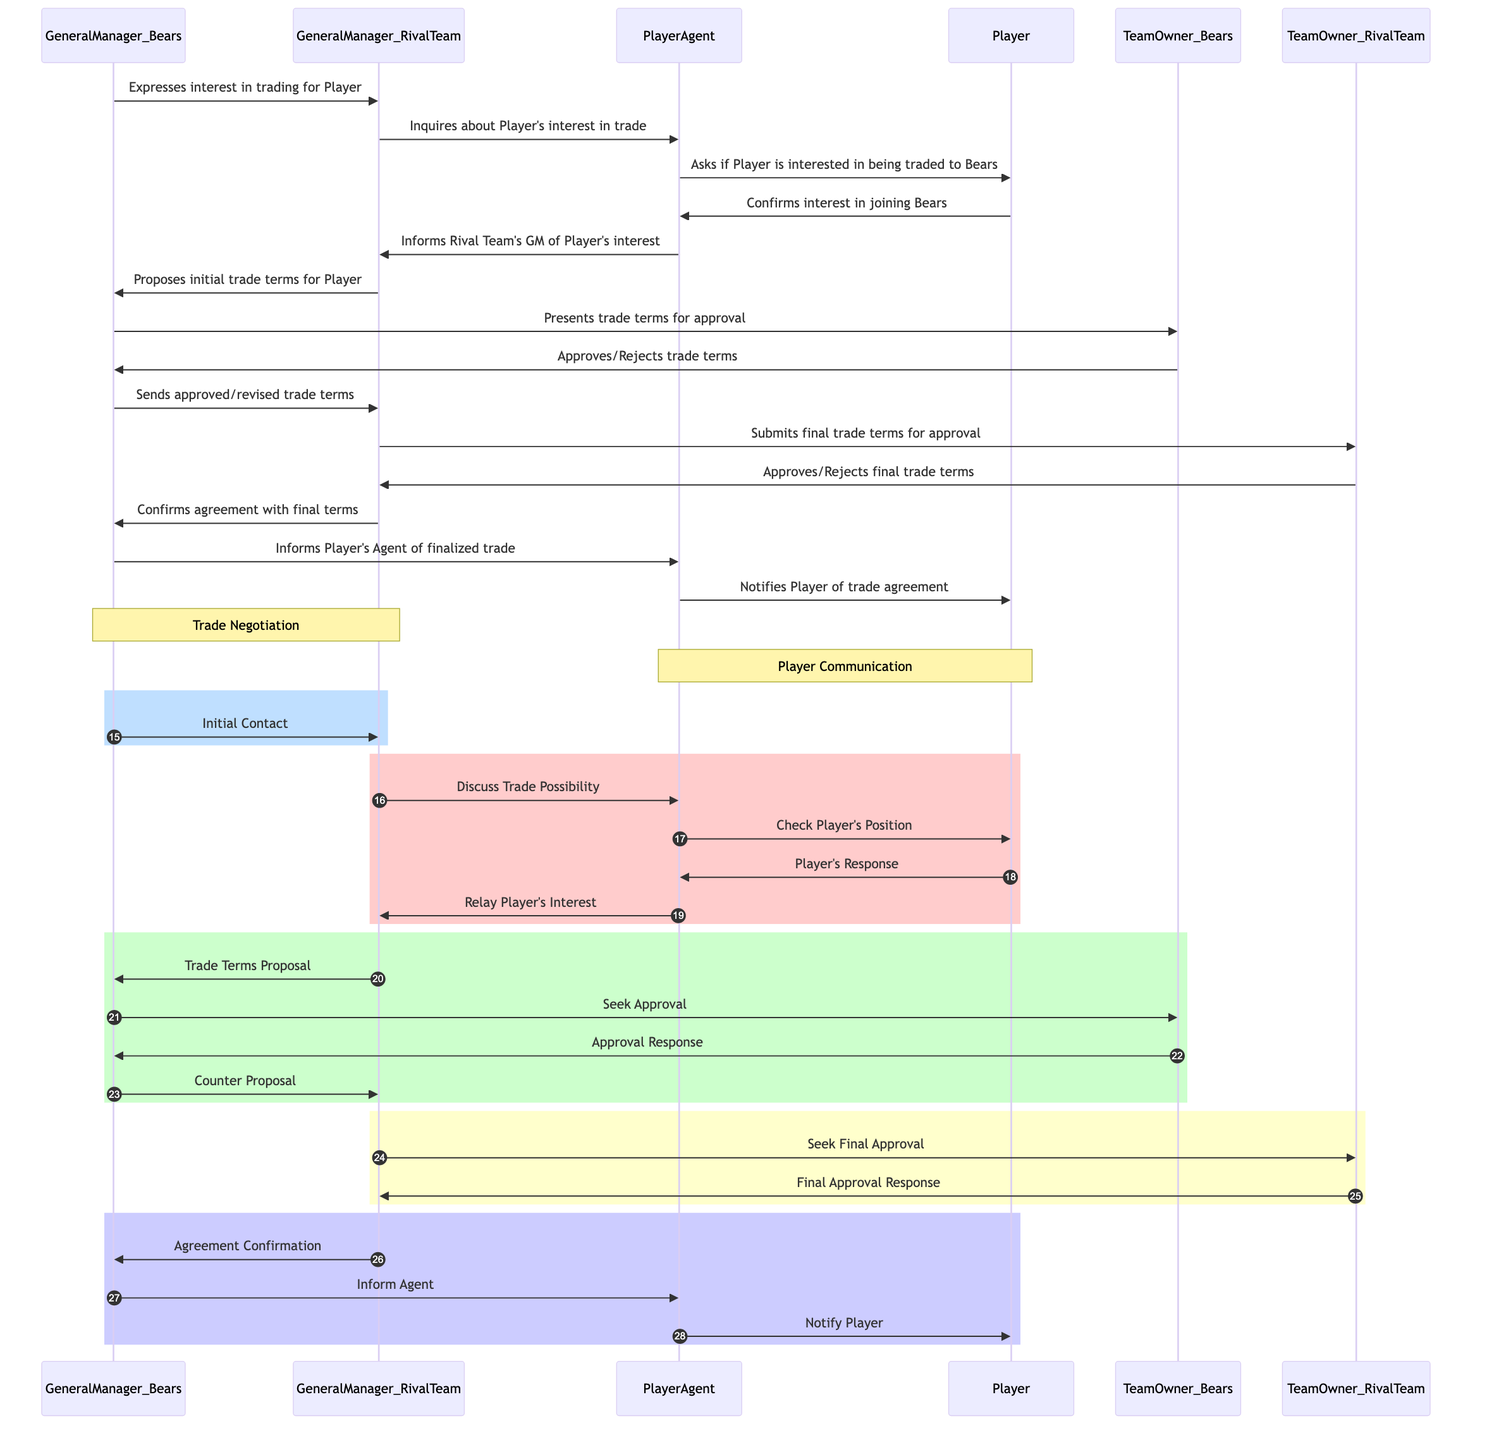What is the first action taken in the trade negotiation? The first action is taken by GeneralManager_Bears, who expresses interest in trading for the Player. This is indicated as the first message in the diagram.
Answer: Expresses interest in trading for Player How many participants are involved in the trade negotiation? There are six distinct participants depicted in the diagram: GeneralManager_Bears, GeneralManager_RivalTeam, PlayerAgent, Player, TeamOwner_Bears, and TeamOwner_RivalTeam.
Answer: Six What message is sent from PlayerAgent to Player? PlayerAgent asks the Player if he is interested in being traded to the Bears. This direct inquiry is listed in the sequence of messages exchanged.
Answer: Asks if Player is interested in being traded to Bears Who gives the final approval for the trade terms from the Rival Team? The final approval for the trade terms from the Rival Team is given by TeamOwner_RivalTeam. This is indicated as the last step before agreement confirmation.
Answer: TeamOwner_RivalTeam What does GeneralManager_Bears do after receiving approval from TeamOwner_Bears? After receiving approval from TeamOwner_Bears, GeneralManager_Bears sends approved or revised trade terms to GeneralManager_RivalTeam. This action follows immediately after approval response.
Answer: Sends approved/revised trade terms What is the last message exchanged in the trade negotiation sequence? The last message exchanged in the trade negotiation sequence is Agreement Confirmation from GeneralManager_RivalTeam to GeneralManager_Bears. This indicates that both parties have finalized the terms of the trade.
Answer: Confirms agreement with final terms What role does PlayerAgent play in this negotiation process? PlayerAgent acts as the intermediary, relaying the Player's interest and notifying both the player and the General Managers about key decisions and responses throughout the negotiation.
Answer: Agent of the Player to be Traded Which participant initiates the trade proposal? GeneralManager_RivalTeam is the participant who initiates the trade proposal by proposing the initial trade terms for the Player after he has confirmed interest.
Answer: GeneralManager_RivalTeam 